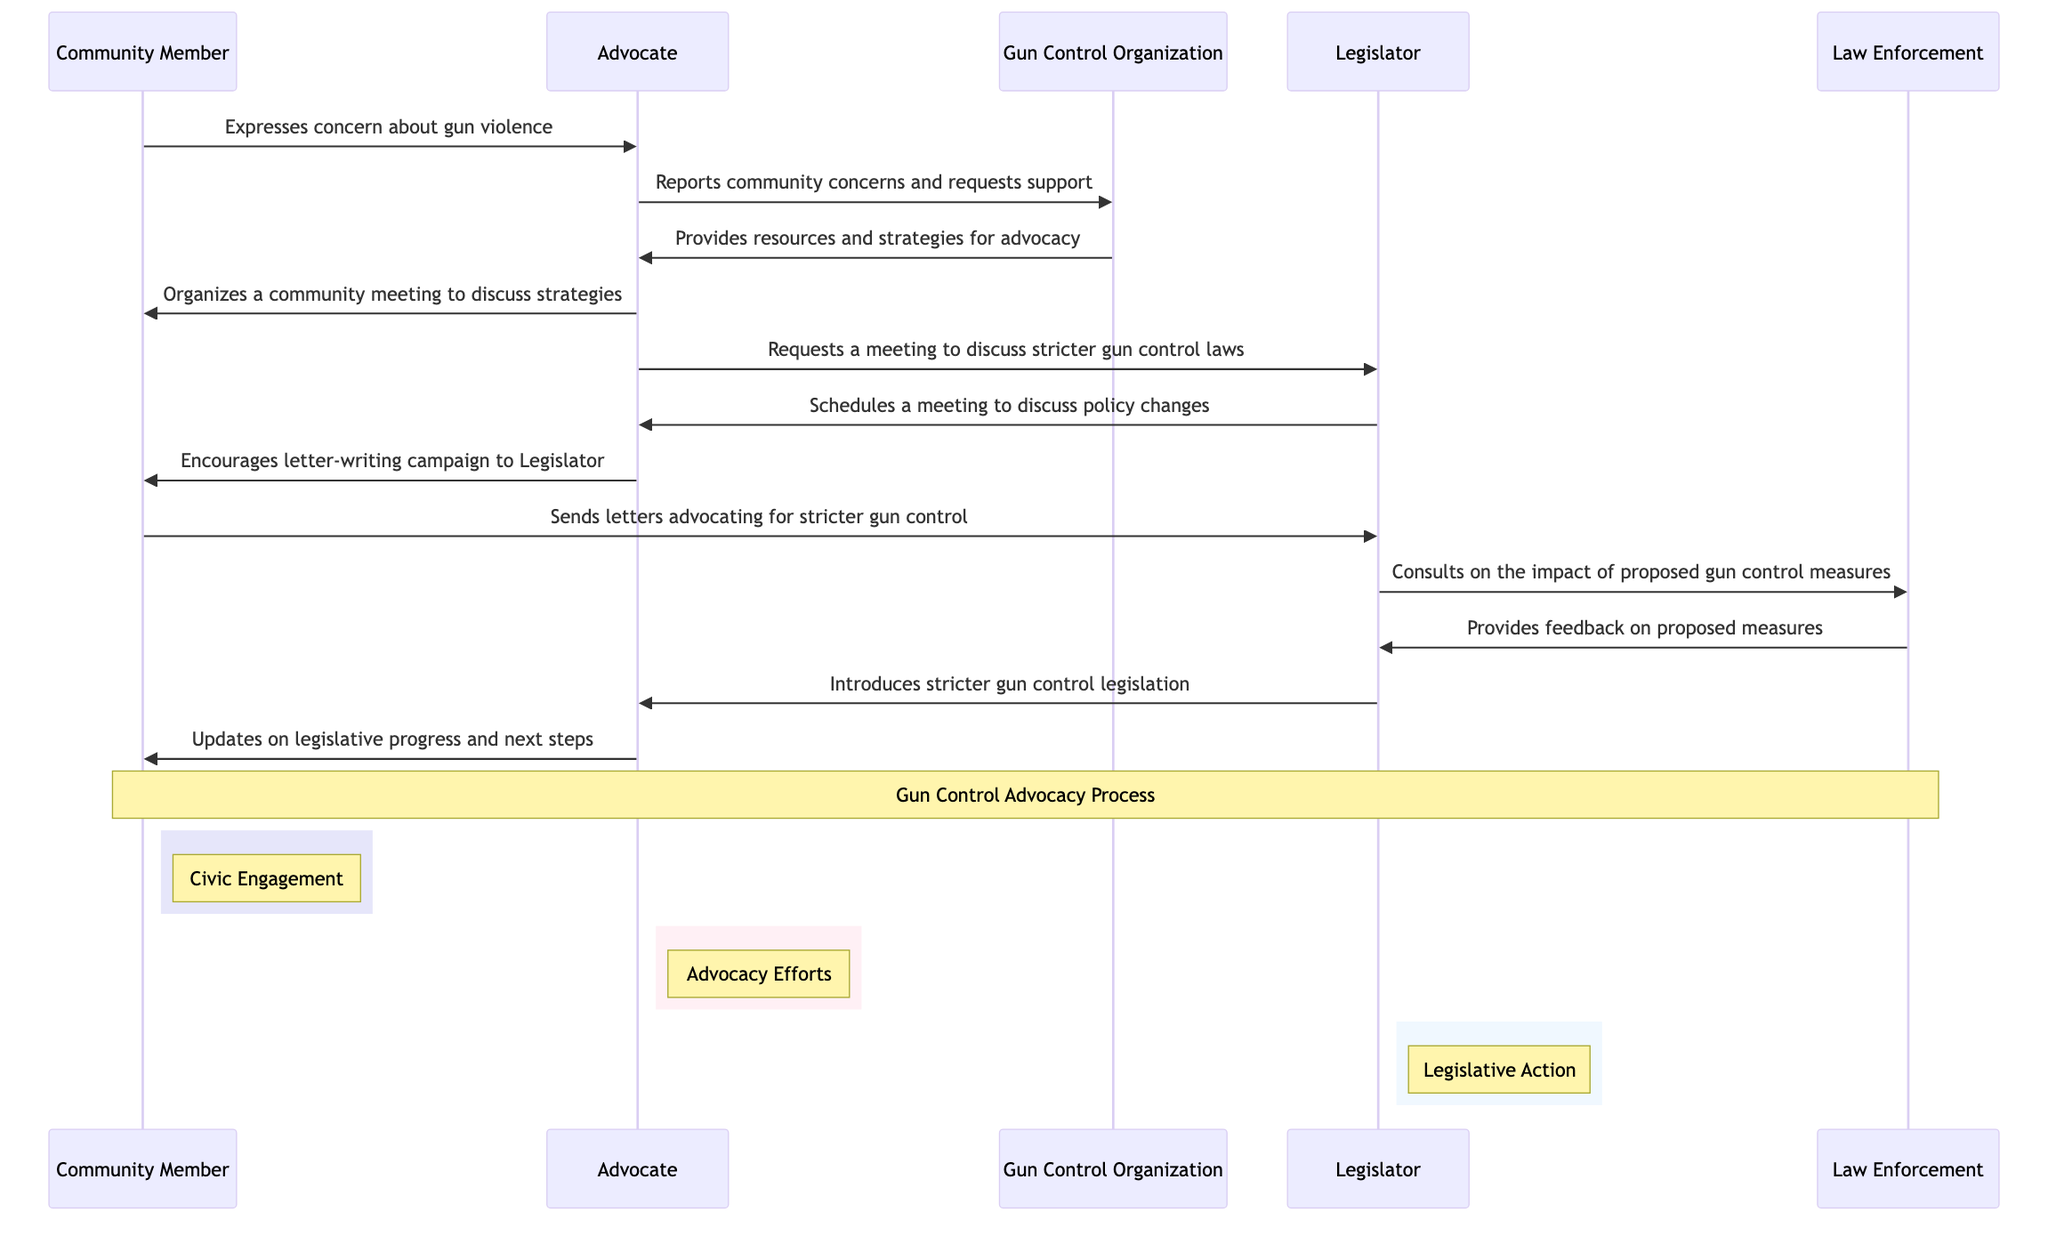What is the first message in the sequence? The first message is from the Community Member to the Advocate, expressing concern about gun violence.
Answer: Expresses concern about gun violence How many participants are involved in the advocacy process? The diagram shows five participants: Community Member, Advocate, Gun Control Organization, Legislator, and Law Enforcement.
Answer: Five Who does the Advocate report community concerns to? The Advocate reports community concerns to the Gun Control Organization to seek support.
Answer: Gun Control Organization What does the Advocate encourage the Community Member to do? The Advocate encourages the Community Member to participate in a letter-writing campaign directed at the Legislator.
Answer: Letter-writing campaign What is the reaction of the Legislator after being contacted by the Advocate? The Legislator schedules a meeting with the Advocate to discuss policy changes regarding gun control laws.
Answer: Schedules a meeting to discuss policy changes What kind of feedback does Law Enforcement provide? Law Enforcement provides feedback on the proposed gun control measures after consulting with the Legislator.
Answer: Feedback on proposed measures What key action does the Legislator take after feedback from the Law Enforcement? After consulting with Law Enforcement, the Legislator introduces stricter gun control legislation.
Answer: Introduces stricter gun control legislation How many messages does the Advocate send in total? The Advocate sends four messages throughout the advocacy process: reporting to the Gun Control Organization, organizing a community meeting, requesting a meeting with the Legislator, and encouraging a letter-writing campaign.
Answer: Four What is the note over the Community Member and Law Enforcement indicating? The note signifies the overall topic of the sequence, encapsulating the entire Gun Control Advocacy Process focused on civic engagement, advocacy efforts, and legislative action.
Answer: Gun Control Advocacy Process 